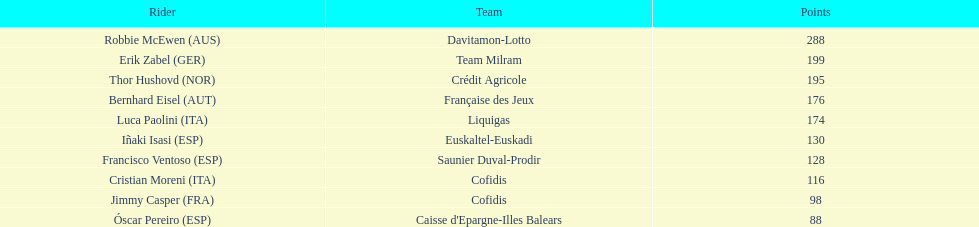How many more points did erik zabel score than franciso ventoso? 71. 